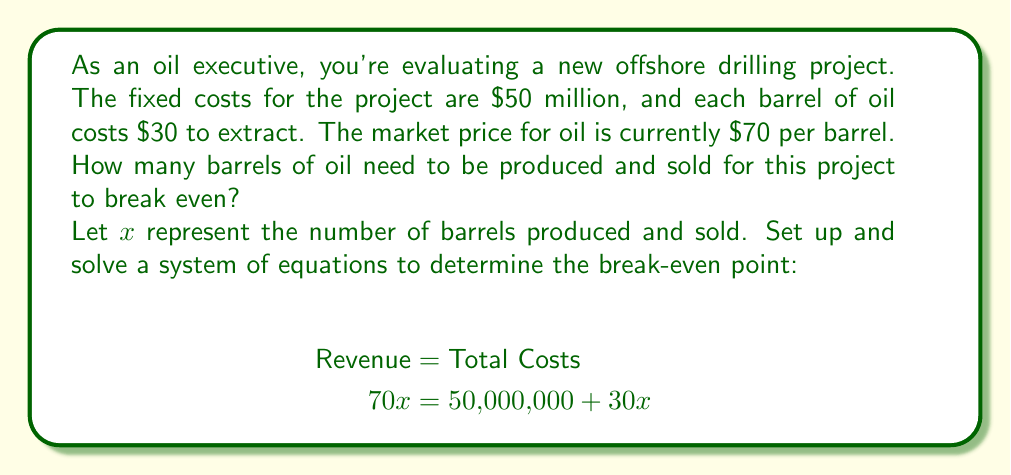Solve this math problem. To solve this problem, we'll follow these steps:

1) Set up the equation:
   $$70x = 50,000,000 + 30x$$

2) Subtract 30x from both sides:
   $$40x = 50,000,000$$

3) Divide both sides by 40:
   $$x = \frac{50,000,000}{40} = 1,250,000$$

4) Check the solution:
   Revenue: $70 * 1,250,000 = 87,500,000$
   Total Costs: $50,000,000 + (30 * 1,250,000) = 87,500,000$

The revenue equals the total costs at 1,250,000 barrels, confirming this is the break-even point.
Answer: 1,250,000 barrels 